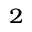Convert formula to latex. <formula><loc_0><loc_0><loc_500><loc_500>^ { 2 }</formula> 